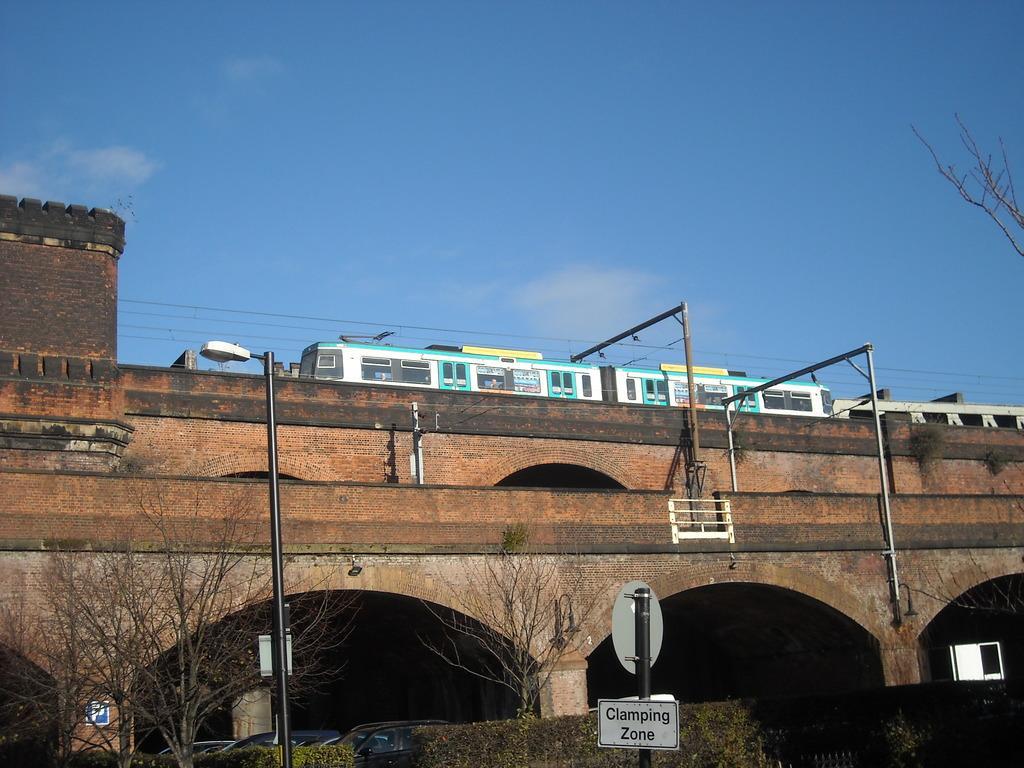Could you give a brief overview of what you see in this image? In this image there are poles, boards, light, trees, vehicles, plants, rods, arches, railing, train, bridge, wall and sky. 